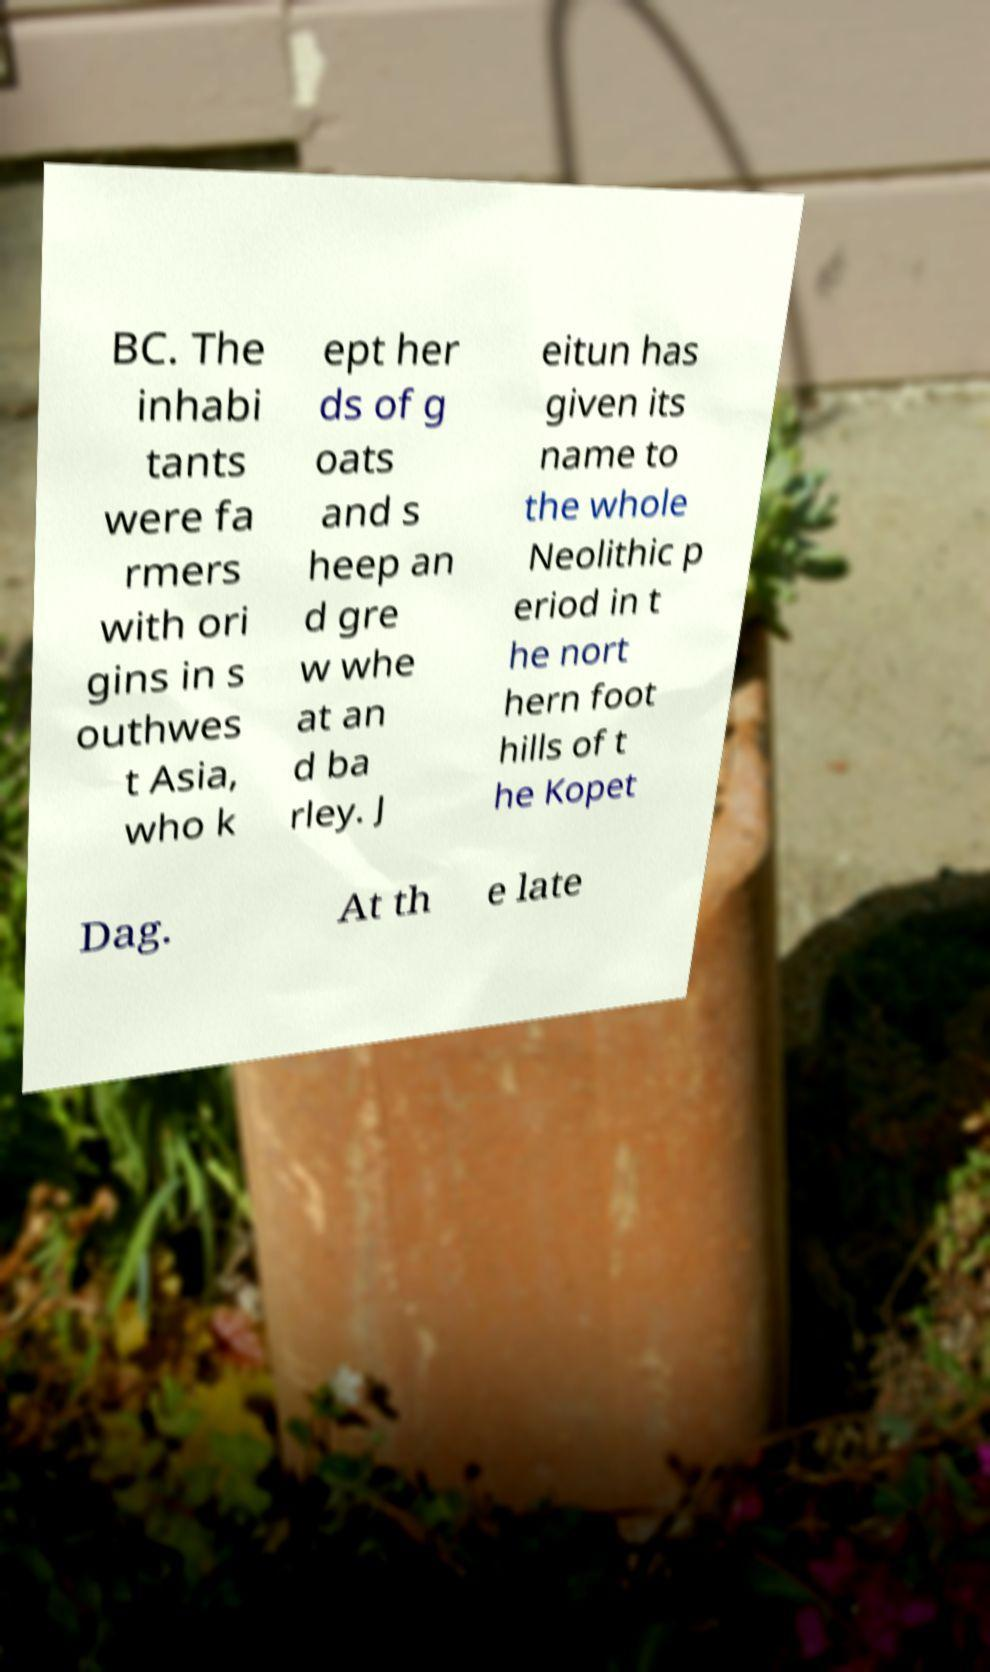I need the written content from this picture converted into text. Can you do that? BC. The inhabi tants were fa rmers with ori gins in s outhwes t Asia, who k ept her ds of g oats and s heep an d gre w whe at an d ba rley. J eitun has given its name to the whole Neolithic p eriod in t he nort hern foot hills of t he Kopet Dag. At th e late 